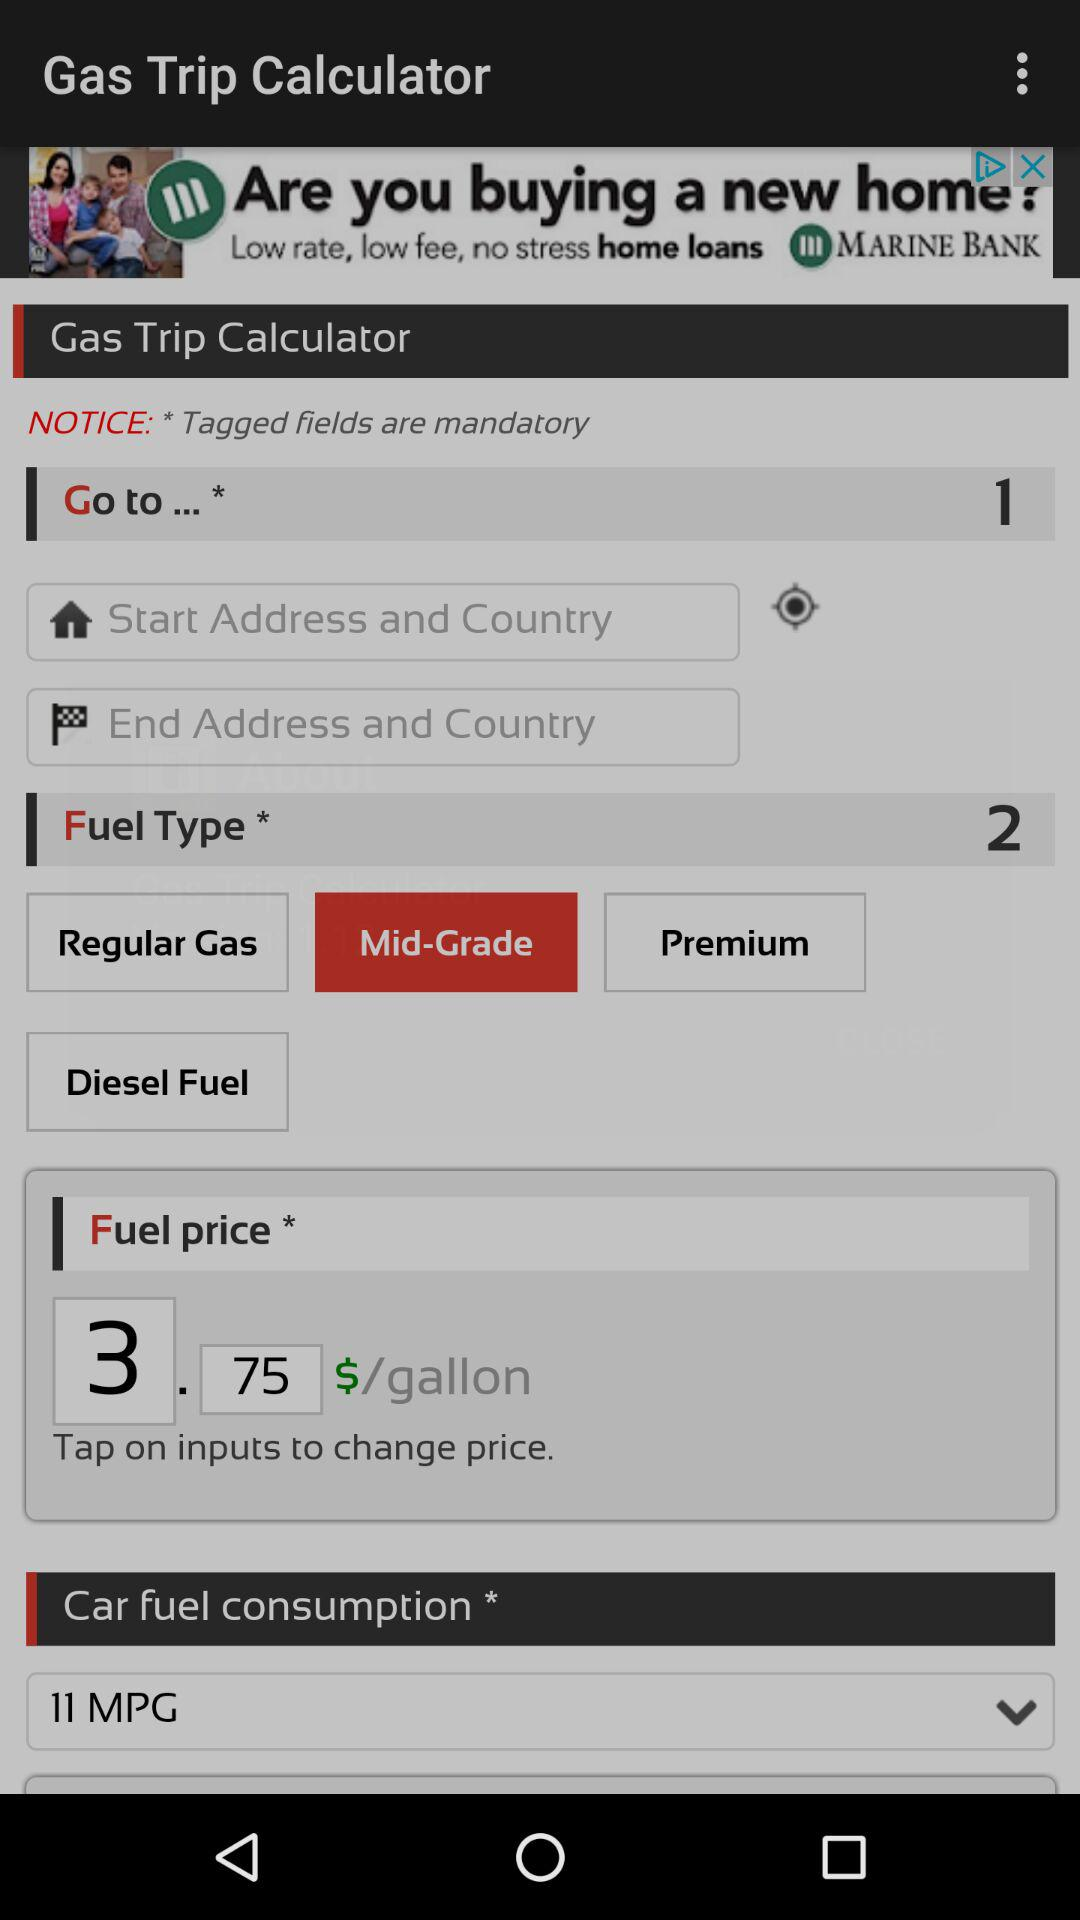What is the car fuel consumption? The car fuel consumption is 11 MPG. 